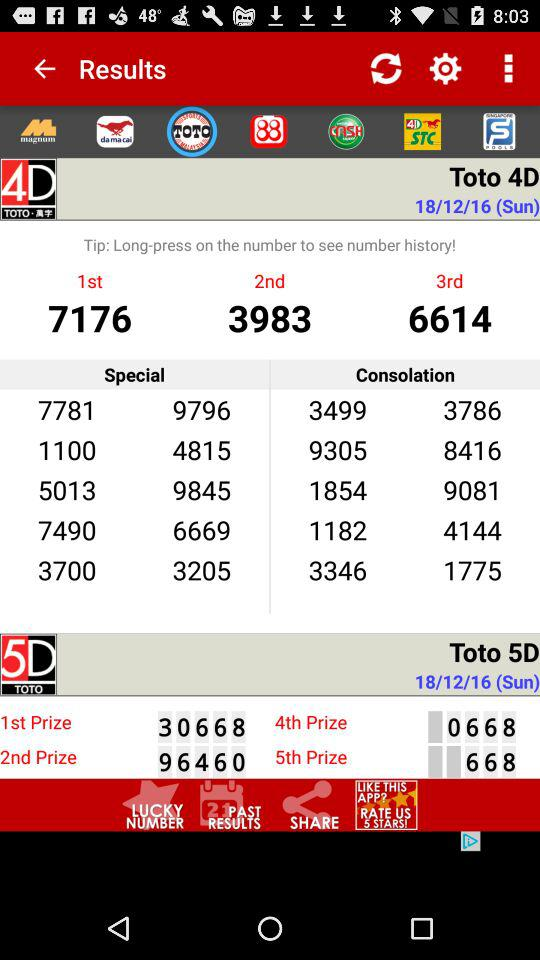What is the number for the second prize in "Toto 4D"? The number is 3983. 